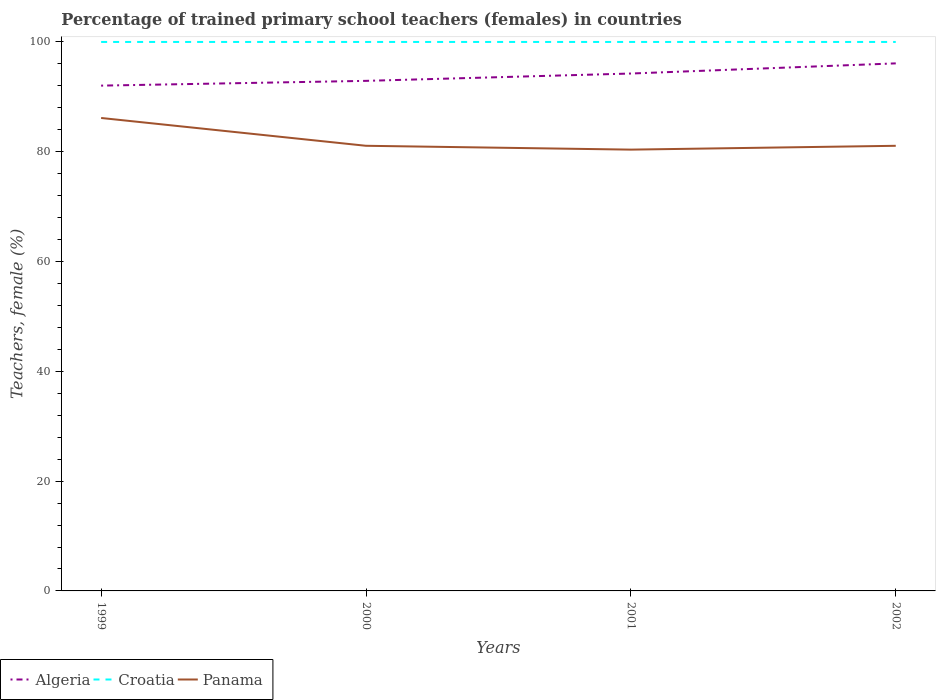How many different coloured lines are there?
Give a very brief answer. 3. Does the line corresponding to Panama intersect with the line corresponding to Algeria?
Provide a succinct answer. No. Across all years, what is the maximum percentage of trained primary school teachers (females) in Croatia?
Offer a terse response. 100. In which year was the percentage of trained primary school teachers (females) in Croatia maximum?
Give a very brief answer. 1999. What is the difference between the highest and the second highest percentage of trained primary school teachers (females) in Algeria?
Make the answer very short. 4.05. What is the difference between the highest and the lowest percentage of trained primary school teachers (females) in Algeria?
Offer a terse response. 2. Is the percentage of trained primary school teachers (females) in Algeria strictly greater than the percentage of trained primary school teachers (females) in Panama over the years?
Offer a terse response. No. How many lines are there?
Provide a succinct answer. 3. What is the difference between two consecutive major ticks on the Y-axis?
Offer a terse response. 20. Are the values on the major ticks of Y-axis written in scientific E-notation?
Your answer should be very brief. No. Does the graph contain any zero values?
Provide a short and direct response. No. Where does the legend appear in the graph?
Your response must be concise. Bottom left. What is the title of the graph?
Keep it short and to the point. Percentage of trained primary school teachers (females) in countries. Does "Slovenia" appear as one of the legend labels in the graph?
Your response must be concise. No. What is the label or title of the X-axis?
Give a very brief answer. Years. What is the label or title of the Y-axis?
Give a very brief answer. Teachers, female (%). What is the Teachers, female (%) in Algeria in 1999?
Make the answer very short. 92.05. What is the Teachers, female (%) in Panama in 1999?
Make the answer very short. 86.15. What is the Teachers, female (%) in Algeria in 2000?
Provide a succinct answer. 92.91. What is the Teachers, female (%) of Croatia in 2000?
Provide a succinct answer. 100. What is the Teachers, female (%) of Panama in 2000?
Your answer should be very brief. 81.09. What is the Teachers, female (%) in Algeria in 2001?
Provide a succinct answer. 94.25. What is the Teachers, female (%) in Panama in 2001?
Your answer should be compact. 80.39. What is the Teachers, female (%) of Algeria in 2002?
Give a very brief answer. 96.1. What is the Teachers, female (%) in Panama in 2002?
Your answer should be compact. 81.09. Across all years, what is the maximum Teachers, female (%) in Algeria?
Your response must be concise. 96.1. Across all years, what is the maximum Teachers, female (%) in Croatia?
Your response must be concise. 100. Across all years, what is the maximum Teachers, female (%) in Panama?
Provide a succinct answer. 86.15. Across all years, what is the minimum Teachers, female (%) in Algeria?
Offer a terse response. 92.05. Across all years, what is the minimum Teachers, female (%) in Panama?
Offer a very short reply. 80.39. What is the total Teachers, female (%) in Algeria in the graph?
Provide a succinct answer. 375.31. What is the total Teachers, female (%) of Croatia in the graph?
Ensure brevity in your answer.  400. What is the total Teachers, female (%) of Panama in the graph?
Your answer should be compact. 328.71. What is the difference between the Teachers, female (%) in Algeria in 1999 and that in 2000?
Your response must be concise. -0.87. What is the difference between the Teachers, female (%) in Croatia in 1999 and that in 2000?
Make the answer very short. 0. What is the difference between the Teachers, female (%) of Panama in 1999 and that in 2000?
Provide a short and direct response. 5.07. What is the difference between the Teachers, female (%) in Algeria in 1999 and that in 2001?
Offer a terse response. -2.2. What is the difference between the Teachers, female (%) in Panama in 1999 and that in 2001?
Your answer should be very brief. 5.76. What is the difference between the Teachers, female (%) in Algeria in 1999 and that in 2002?
Keep it short and to the point. -4.05. What is the difference between the Teachers, female (%) in Panama in 1999 and that in 2002?
Your answer should be compact. 5.07. What is the difference between the Teachers, female (%) in Algeria in 2000 and that in 2001?
Provide a succinct answer. -1.34. What is the difference between the Teachers, female (%) of Panama in 2000 and that in 2001?
Give a very brief answer. 0.7. What is the difference between the Teachers, female (%) in Algeria in 2000 and that in 2002?
Your response must be concise. -3.18. What is the difference between the Teachers, female (%) of Croatia in 2000 and that in 2002?
Offer a terse response. 0. What is the difference between the Teachers, female (%) in Panama in 2000 and that in 2002?
Offer a very short reply. 0. What is the difference between the Teachers, female (%) of Algeria in 2001 and that in 2002?
Provide a succinct answer. -1.85. What is the difference between the Teachers, female (%) in Croatia in 2001 and that in 2002?
Give a very brief answer. 0. What is the difference between the Teachers, female (%) in Panama in 2001 and that in 2002?
Your answer should be compact. -0.7. What is the difference between the Teachers, female (%) of Algeria in 1999 and the Teachers, female (%) of Croatia in 2000?
Provide a succinct answer. -7.95. What is the difference between the Teachers, female (%) of Algeria in 1999 and the Teachers, female (%) of Panama in 2000?
Provide a short and direct response. 10.96. What is the difference between the Teachers, female (%) of Croatia in 1999 and the Teachers, female (%) of Panama in 2000?
Provide a succinct answer. 18.91. What is the difference between the Teachers, female (%) of Algeria in 1999 and the Teachers, female (%) of Croatia in 2001?
Your answer should be very brief. -7.95. What is the difference between the Teachers, female (%) in Algeria in 1999 and the Teachers, female (%) in Panama in 2001?
Keep it short and to the point. 11.66. What is the difference between the Teachers, female (%) in Croatia in 1999 and the Teachers, female (%) in Panama in 2001?
Give a very brief answer. 19.61. What is the difference between the Teachers, female (%) of Algeria in 1999 and the Teachers, female (%) of Croatia in 2002?
Provide a succinct answer. -7.95. What is the difference between the Teachers, female (%) of Algeria in 1999 and the Teachers, female (%) of Panama in 2002?
Give a very brief answer. 10.96. What is the difference between the Teachers, female (%) in Croatia in 1999 and the Teachers, female (%) in Panama in 2002?
Provide a short and direct response. 18.91. What is the difference between the Teachers, female (%) in Algeria in 2000 and the Teachers, female (%) in Croatia in 2001?
Give a very brief answer. -7.09. What is the difference between the Teachers, female (%) of Algeria in 2000 and the Teachers, female (%) of Panama in 2001?
Ensure brevity in your answer.  12.53. What is the difference between the Teachers, female (%) of Croatia in 2000 and the Teachers, female (%) of Panama in 2001?
Keep it short and to the point. 19.61. What is the difference between the Teachers, female (%) of Algeria in 2000 and the Teachers, female (%) of Croatia in 2002?
Provide a short and direct response. -7.09. What is the difference between the Teachers, female (%) in Algeria in 2000 and the Teachers, female (%) in Panama in 2002?
Your answer should be very brief. 11.83. What is the difference between the Teachers, female (%) of Croatia in 2000 and the Teachers, female (%) of Panama in 2002?
Offer a very short reply. 18.91. What is the difference between the Teachers, female (%) in Algeria in 2001 and the Teachers, female (%) in Croatia in 2002?
Your answer should be compact. -5.75. What is the difference between the Teachers, female (%) of Algeria in 2001 and the Teachers, female (%) of Panama in 2002?
Provide a short and direct response. 13.16. What is the difference between the Teachers, female (%) in Croatia in 2001 and the Teachers, female (%) in Panama in 2002?
Ensure brevity in your answer.  18.91. What is the average Teachers, female (%) of Algeria per year?
Offer a very short reply. 93.83. What is the average Teachers, female (%) of Panama per year?
Provide a succinct answer. 82.18. In the year 1999, what is the difference between the Teachers, female (%) of Algeria and Teachers, female (%) of Croatia?
Give a very brief answer. -7.95. In the year 1999, what is the difference between the Teachers, female (%) in Algeria and Teachers, female (%) in Panama?
Give a very brief answer. 5.89. In the year 1999, what is the difference between the Teachers, female (%) in Croatia and Teachers, female (%) in Panama?
Your answer should be very brief. 13.85. In the year 2000, what is the difference between the Teachers, female (%) of Algeria and Teachers, female (%) of Croatia?
Provide a succinct answer. -7.09. In the year 2000, what is the difference between the Teachers, female (%) in Algeria and Teachers, female (%) in Panama?
Provide a short and direct response. 11.83. In the year 2000, what is the difference between the Teachers, female (%) of Croatia and Teachers, female (%) of Panama?
Provide a short and direct response. 18.91. In the year 2001, what is the difference between the Teachers, female (%) of Algeria and Teachers, female (%) of Croatia?
Your answer should be very brief. -5.75. In the year 2001, what is the difference between the Teachers, female (%) of Algeria and Teachers, female (%) of Panama?
Keep it short and to the point. 13.86. In the year 2001, what is the difference between the Teachers, female (%) in Croatia and Teachers, female (%) in Panama?
Provide a succinct answer. 19.61. In the year 2002, what is the difference between the Teachers, female (%) in Algeria and Teachers, female (%) in Croatia?
Ensure brevity in your answer.  -3.9. In the year 2002, what is the difference between the Teachers, female (%) of Algeria and Teachers, female (%) of Panama?
Give a very brief answer. 15.01. In the year 2002, what is the difference between the Teachers, female (%) in Croatia and Teachers, female (%) in Panama?
Give a very brief answer. 18.91. What is the ratio of the Teachers, female (%) of Croatia in 1999 to that in 2000?
Give a very brief answer. 1. What is the ratio of the Teachers, female (%) of Panama in 1999 to that in 2000?
Provide a short and direct response. 1.06. What is the ratio of the Teachers, female (%) in Algeria in 1999 to that in 2001?
Your answer should be compact. 0.98. What is the ratio of the Teachers, female (%) of Panama in 1999 to that in 2001?
Offer a terse response. 1.07. What is the ratio of the Teachers, female (%) of Algeria in 1999 to that in 2002?
Offer a terse response. 0.96. What is the ratio of the Teachers, female (%) of Panama in 1999 to that in 2002?
Provide a succinct answer. 1.06. What is the ratio of the Teachers, female (%) in Algeria in 2000 to that in 2001?
Offer a terse response. 0.99. What is the ratio of the Teachers, female (%) of Panama in 2000 to that in 2001?
Make the answer very short. 1.01. What is the ratio of the Teachers, female (%) in Algeria in 2000 to that in 2002?
Your answer should be compact. 0.97. What is the ratio of the Teachers, female (%) in Croatia in 2000 to that in 2002?
Keep it short and to the point. 1. What is the ratio of the Teachers, female (%) of Panama in 2000 to that in 2002?
Keep it short and to the point. 1. What is the ratio of the Teachers, female (%) of Algeria in 2001 to that in 2002?
Your answer should be very brief. 0.98. What is the ratio of the Teachers, female (%) in Croatia in 2001 to that in 2002?
Your response must be concise. 1. What is the ratio of the Teachers, female (%) of Panama in 2001 to that in 2002?
Ensure brevity in your answer.  0.99. What is the difference between the highest and the second highest Teachers, female (%) of Algeria?
Keep it short and to the point. 1.85. What is the difference between the highest and the second highest Teachers, female (%) of Croatia?
Provide a succinct answer. 0. What is the difference between the highest and the second highest Teachers, female (%) in Panama?
Keep it short and to the point. 5.07. What is the difference between the highest and the lowest Teachers, female (%) of Algeria?
Your response must be concise. 4.05. What is the difference between the highest and the lowest Teachers, female (%) in Croatia?
Your answer should be compact. 0. What is the difference between the highest and the lowest Teachers, female (%) in Panama?
Your answer should be compact. 5.76. 